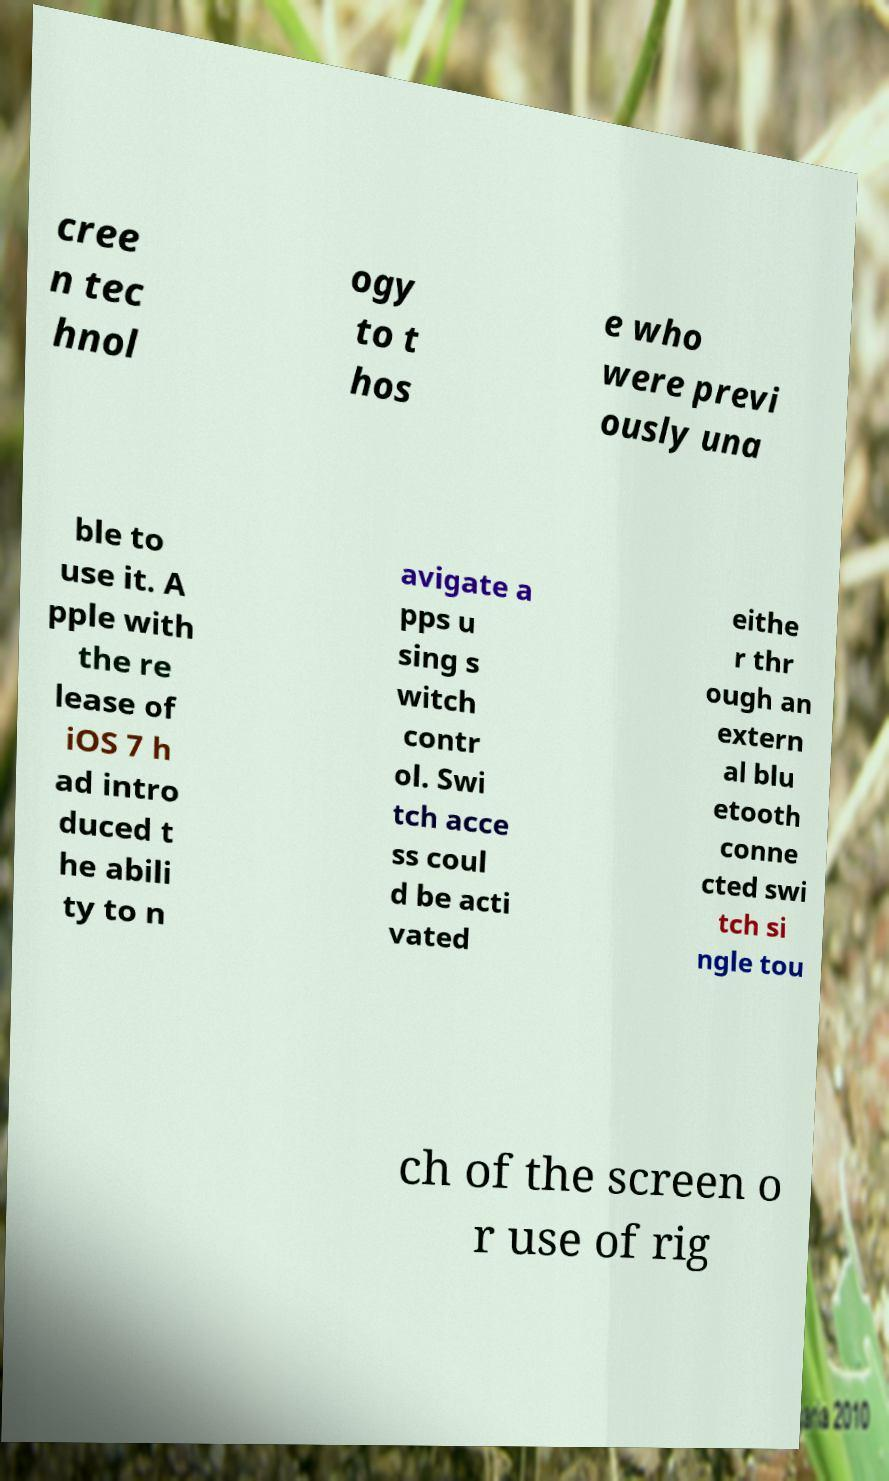I need the written content from this picture converted into text. Can you do that? cree n tec hnol ogy to t hos e who were previ ously una ble to use it. A pple with the re lease of iOS 7 h ad intro duced t he abili ty to n avigate a pps u sing s witch contr ol. Swi tch acce ss coul d be acti vated eithe r thr ough an extern al blu etooth conne cted swi tch si ngle tou ch of the screen o r use of rig 